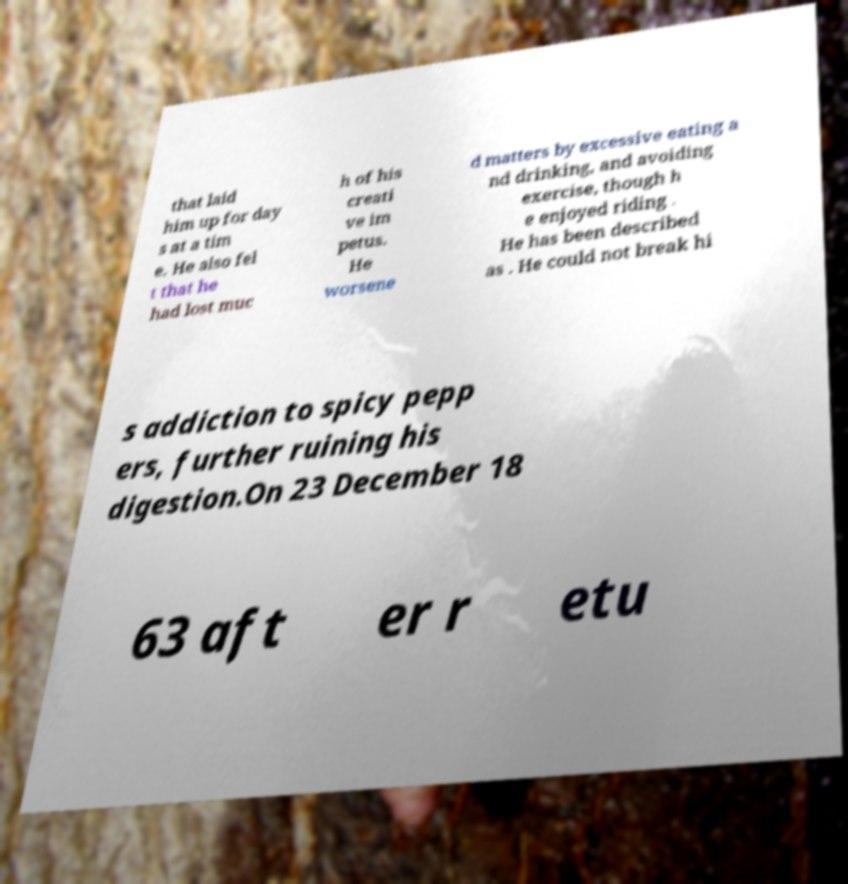For documentation purposes, I need the text within this image transcribed. Could you provide that? that laid him up for day s at a tim e. He also fel t that he had lost muc h of his creati ve im petus. He worsene d matters by excessive eating a nd drinking, and avoiding exercise, though h e enjoyed riding . He has been described as . He could not break hi s addiction to spicy pepp ers, further ruining his digestion.On 23 December 18 63 aft er r etu 